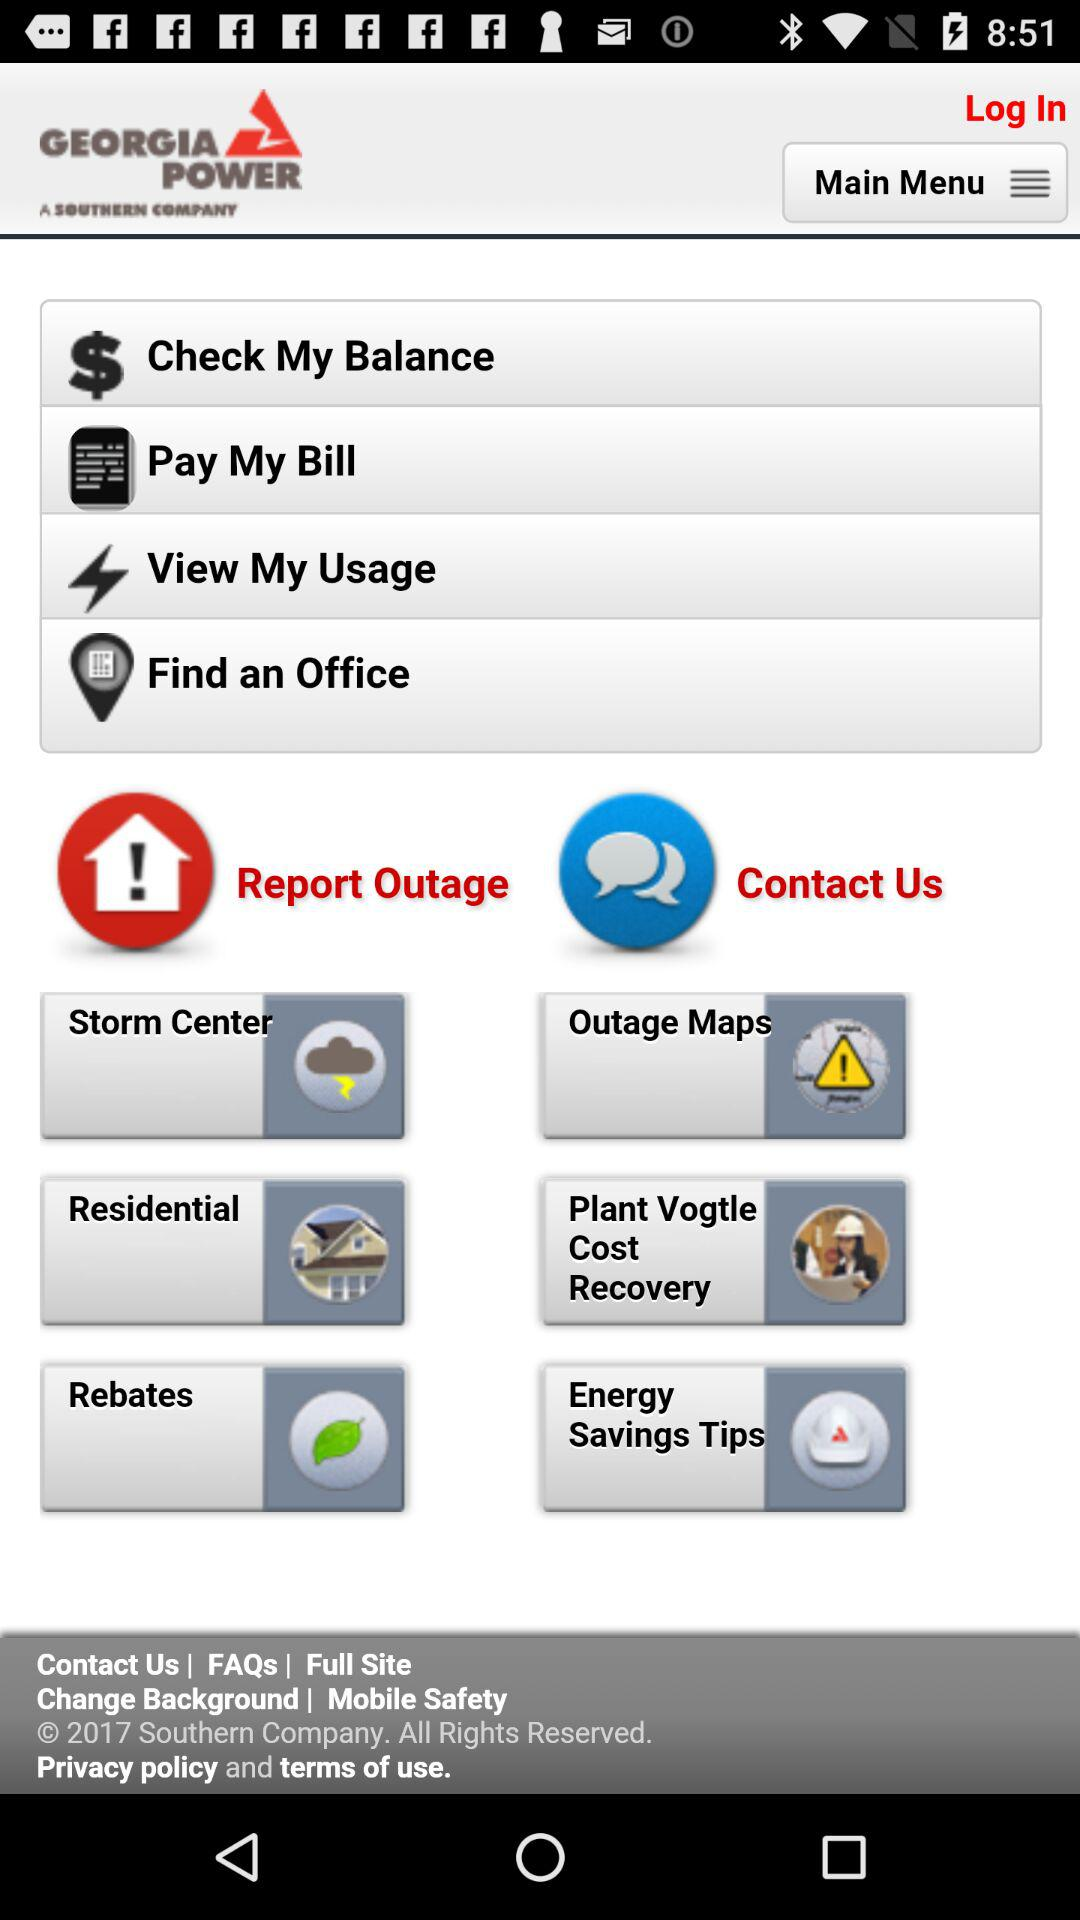What is the application name? The application name is "GEORGIA POWER". 